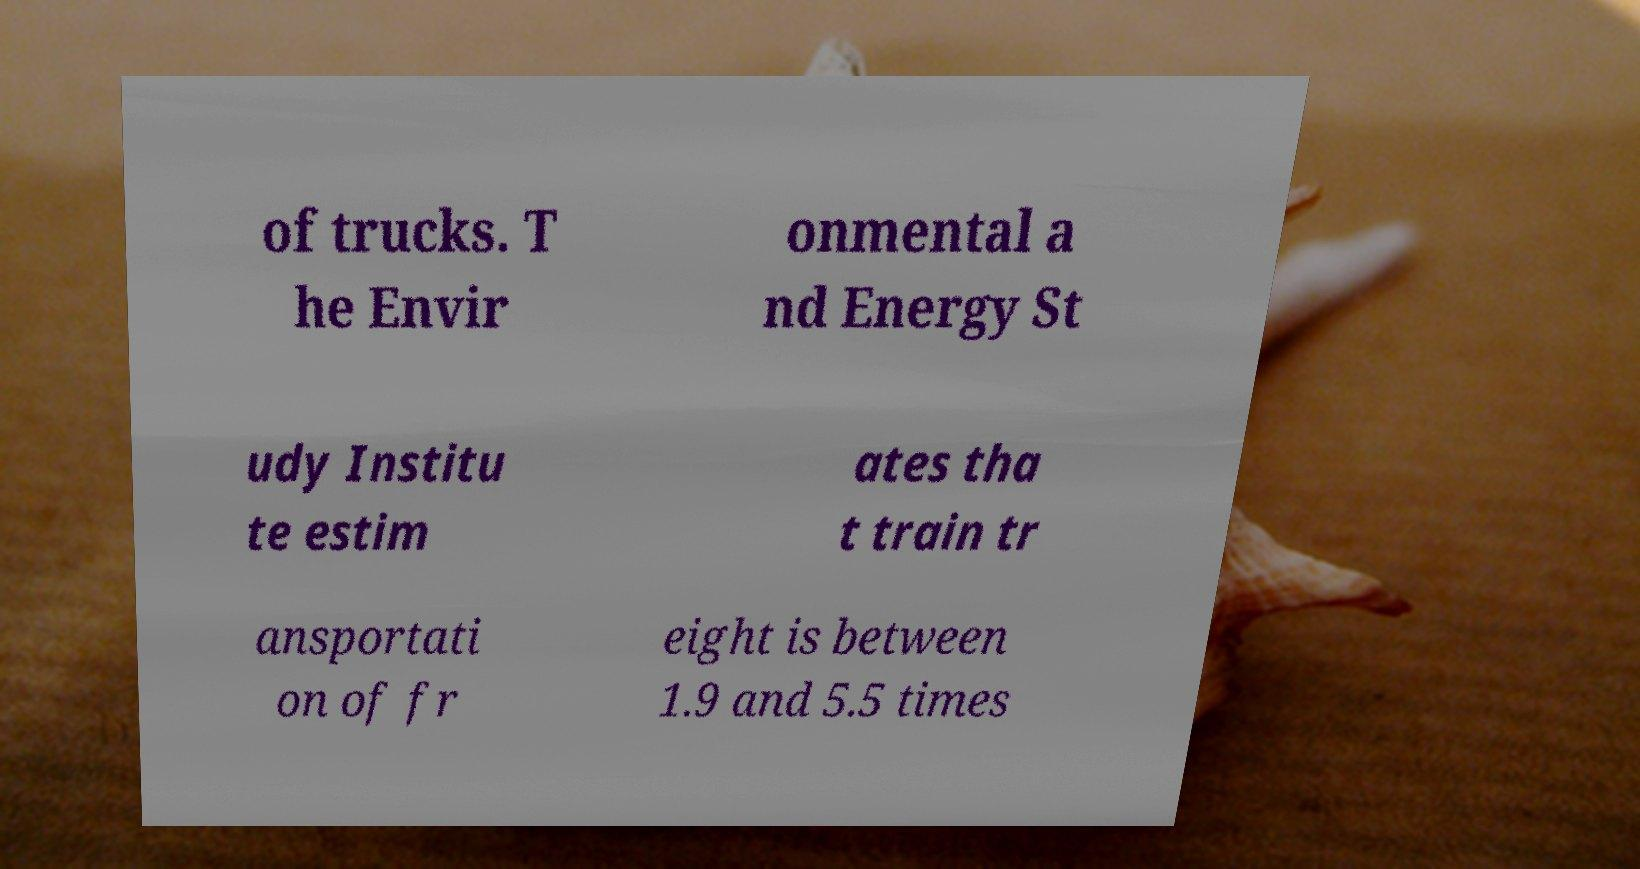Could you extract and type out the text from this image? of trucks. T he Envir onmental a nd Energy St udy Institu te estim ates tha t train tr ansportati on of fr eight is between 1.9 and 5.5 times 